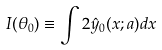Convert formula to latex. <formula><loc_0><loc_0><loc_500><loc_500>I ( \theta _ { 0 } ) \equiv \int 2 \hat { y } _ { 0 } ( x ; a ) d x</formula> 